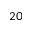Convert formula to latex. <formula><loc_0><loc_0><loc_500><loc_500>2 0</formula> 